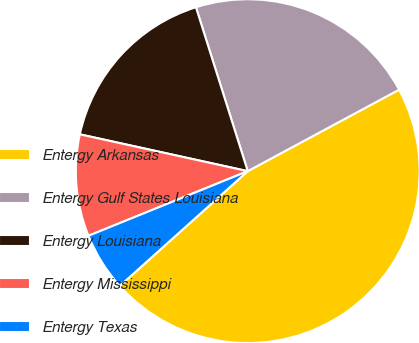Convert chart to OTSL. <chart><loc_0><loc_0><loc_500><loc_500><pie_chart><fcel>Entergy Arkansas<fcel>Entergy Gulf States Louisiana<fcel>Entergy Louisiana<fcel>Entergy Mississippi<fcel>Entergy Texas<nl><fcel>46.22%<fcel>22.01%<fcel>16.69%<fcel>9.57%<fcel>5.5%<nl></chart> 